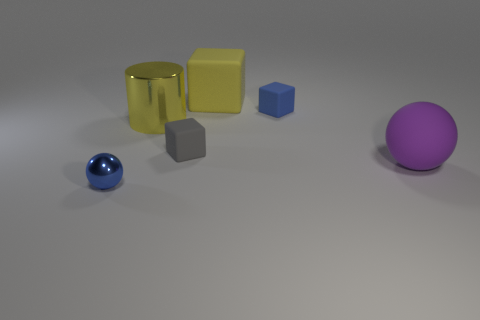Subtract all small blocks. How many blocks are left? 1 Subtract all purple balls. How many balls are left? 1 Add 1 big blue matte things. How many objects exist? 7 Subtract all cylinders. How many objects are left? 5 Subtract 0 brown cubes. How many objects are left? 6 Subtract 1 cylinders. How many cylinders are left? 0 Subtract all cyan cylinders. Subtract all yellow balls. How many cylinders are left? 1 Subtract all red spheres. How many purple cylinders are left? 0 Subtract all large purple rubber spheres. Subtract all rubber blocks. How many objects are left? 2 Add 2 purple matte balls. How many purple matte balls are left? 3 